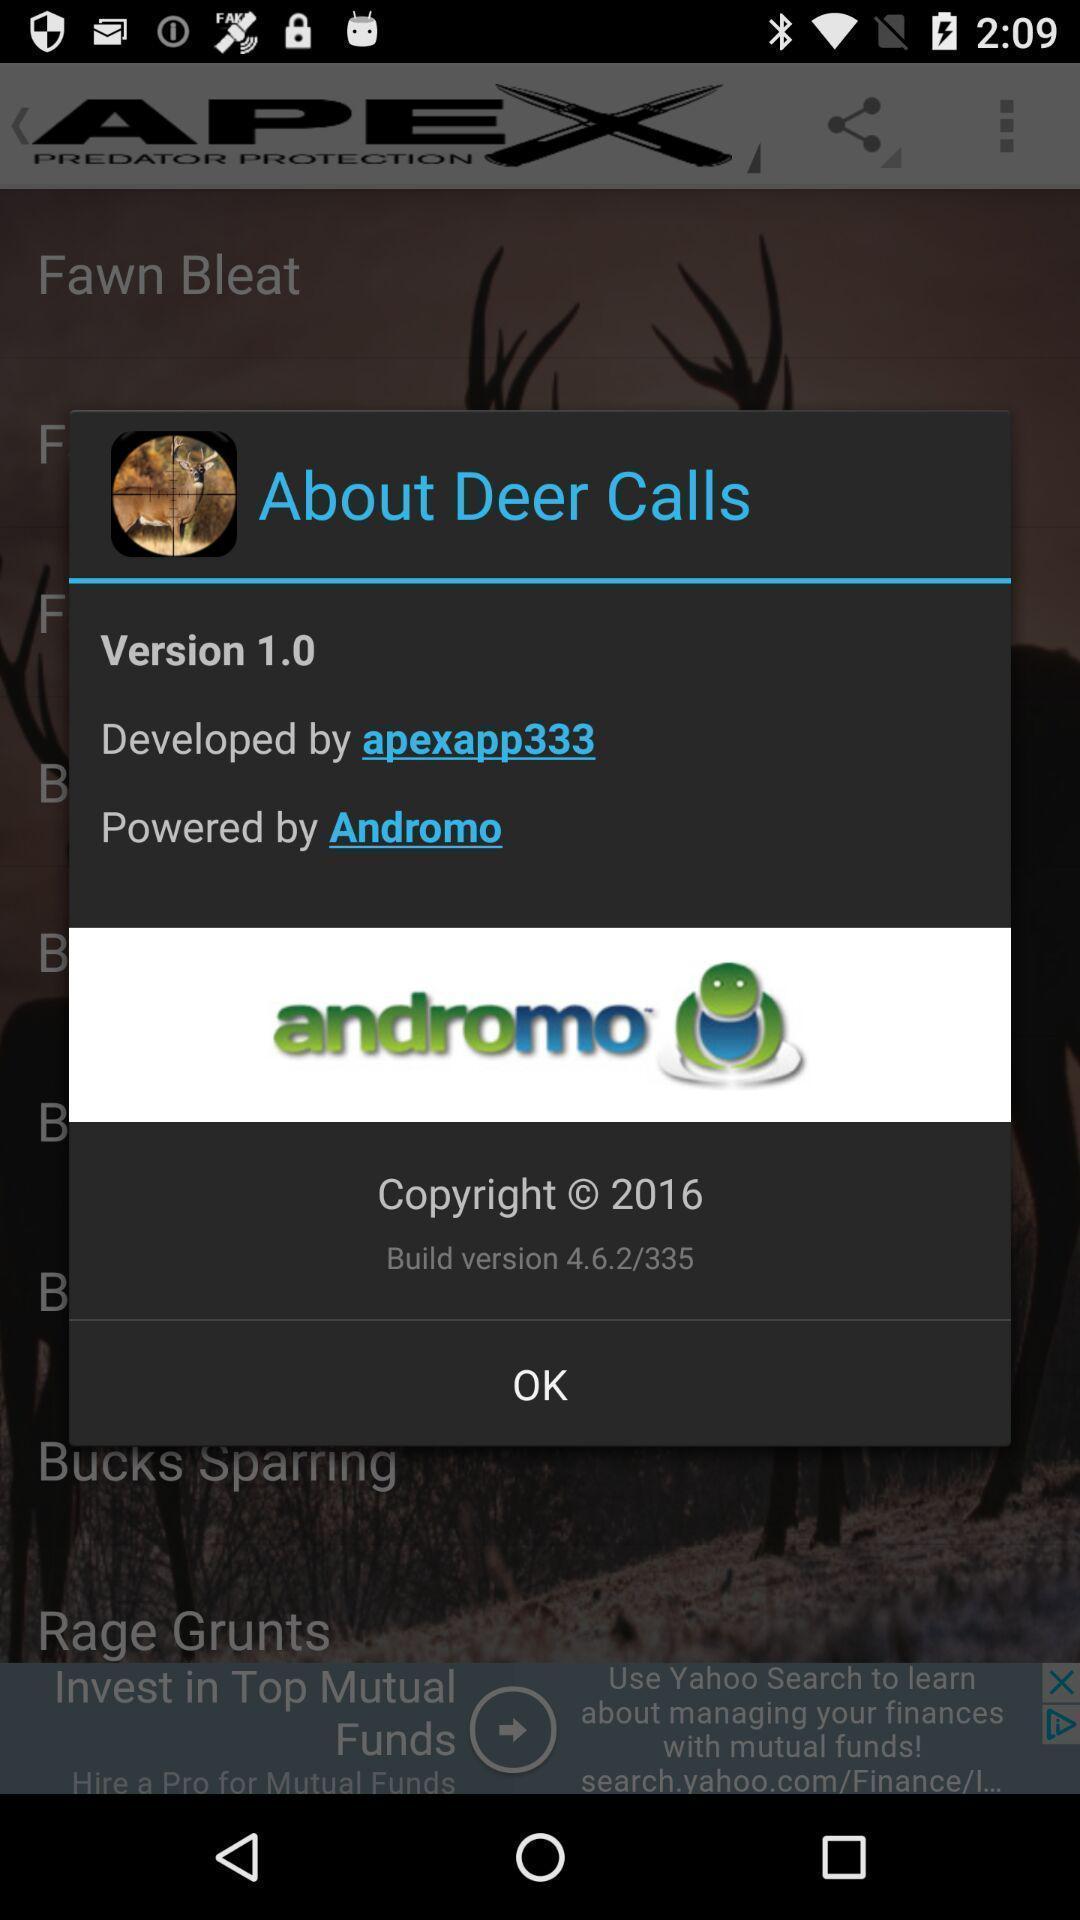What can you discern from this picture? Pop-up showing version of a call app. 